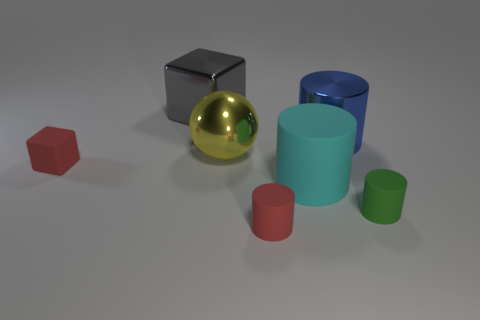What material is the object that is the same color as the matte block?
Make the answer very short. Rubber. How many things are small red metal cylinders or tiny cylinders?
Ensure brevity in your answer.  2. What is the shape of the object that is behind the large blue thing?
Give a very brief answer. Cube. What color is the block that is the same material as the yellow object?
Your answer should be very brief. Gray. What is the material of the big blue object that is the same shape as the big cyan object?
Keep it short and to the point. Metal. There is a gray shiny thing; what shape is it?
Provide a succinct answer. Cube. What is the material of the cylinder that is right of the large rubber object and behind the green cylinder?
Offer a very short reply. Metal. There is a gray object that is the same material as the large yellow sphere; what shape is it?
Make the answer very short. Cube. What size is the cyan cylinder that is made of the same material as the green object?
Make the answer very short. Large. There is a matte thing that is behind the small green object and left of the cyan matte cylinder; what shape is it?
Provide a short and direct response. Cube. 